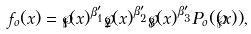<formula> <loc_0><loc_0><loc_500><loc_500>f _ { o } ( x ) = \wp _ { 1 } ( x ) ^ { \beta ^ { \prime } _ { 1 } } \wp _ { 2 } ( x ) ^ { \beta ^ { \prime } _ { 2 } } \wp _ { 3 } ( x ) ^ { \beta ^ { \prime } _ { 3 } } P _ { o } ( \wp ( x ) ) ,</formula> 